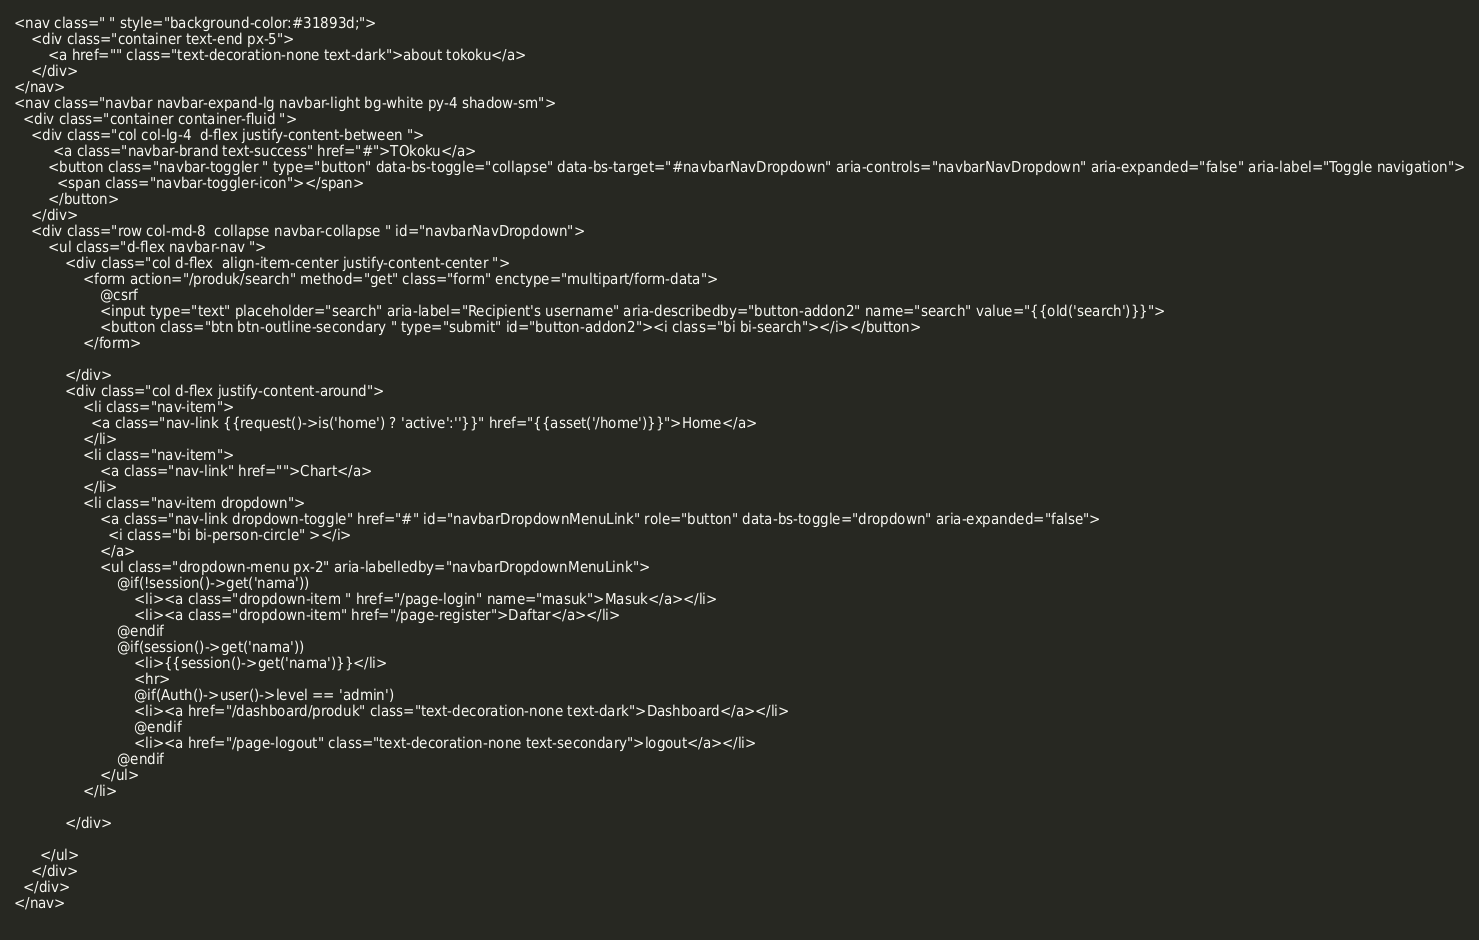Convert code to text. <code><loc_0><loc_0><loc_500><loc_500><_PHP_><nav class=" " style="background-color:#31893d;">
	<div class="container text-end px-5">
		<a href="" class="text-decoration-none text-dark">about tokoku</a>
	</div>
</nav>
<nav class="navbar navbar-expand-lg navbar-light bg-white py-4 shadow-sm">
  <div class="container container-fluid ">
  	<div class="col col-lg-4  d-flex justify-content-between ">
  		 <a class="navbar-brand text-success" href="#">TOkoku</a>
	    <button class="navbar-toggler " type="button" data-bs-toggle="collapse" data-bs-target="#navbarNavDropdown" aria-controls="navbarNavDropdown" aria-expanded="false" aria-label="Toggle navigation">
	      <span class="navbar-toggler-icon"></span>
	    </button>
  	</div>
    <div class="row col-md-8  collapse navbar-collapse " id="navbarNavDropdown">
    	<ul class="d-flex navbar-nav ">
    		<div class="col d-flex  align-item-center justify-content-center ">
    			<form action="/produk/search" method="get" class="form" enctype="multipart/form-data">
    				@csrf
    				<input type="text" placeholder="search" aria-label="Recipient's username" aria-describedby="button-addon2" name="search" value="{{old('search')}}">
					<button class="btn btn-outline-secondary " type="submit" id="button-addon2"><i class="bi bi-search"></i></button>
    			</form>
    			
    		</div>
    		<div class="col d-flex justify-content-around">
    			<li class="nav-item">
		          <a class="nav-link {{request()->is('home') ? 'active':''}}" href="{{asset('/home')}}">Home</a>
		        </li>	
		        <li class="nav-item">
		        	<a class="nav-link" href="">Chart</a>
		        </li>
		        <li class="nav-item dropdown">
			        <a class="nav-link dropdown-toggle" href="#" id="navbarDropdownMenuLink" role="button" data-bs-toggle="dropdown" aria-expanded="false">
			          <i class="bi bi-person-circle" ></i>
			        </a>
			        <ul class="dropdown-menu px-2" aria-labelledby="navbarDropdownMenuLink">
			            @if(!session()->get('nama'))
							<li><a class="dropdown-item " href="/page-login" name="masuk">Masuk</a></li>
							<li><a class="dropdown-item" href="/page-register">Daftar</a></li>
						@endif
						@if(session()->get('nama'))
							<li>{{session()->get('nama')}}</li>
							<hr>
							@if(Auth()->user()->level == 'admin')
							<li><a href="/dashboard/produk" class="text-decoration-none text-dark">Dashboard</a></li>
							@endif
							<li><a href="/page-logout" class="text-decoration-none text-secondary">logout</a></li>
						@endif    		
			        </ul>
	       		</li>
	       		
    		</div>
	       
      </ul>
    </div>
  </div>
</nav>
	</code> 